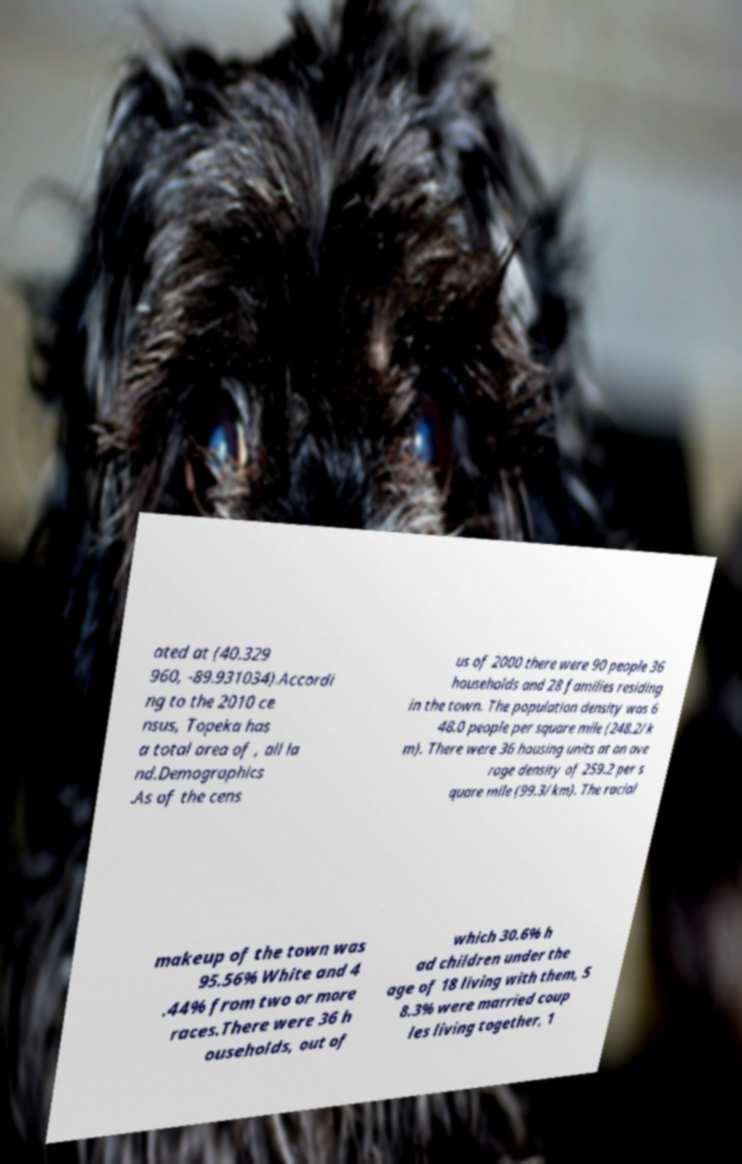Can you read and provide the text displayed in the image?This photo seems to have some interesting text. Can you extract and type it out for me? ated at (40.329 960, -89.931034).Accordi ng to the 2010 ce nsus, Topeka has a total area of , all la nd.Demographics .As of the cens us of 2000 there were 90 people 36 households and 28 families residing in the town. The population density was 6 48.0 people per square mile (248.2/k m). There were 36 housing units at an ave rage density of 259.2 per s quare mile (99.3/km). The racial makeup of the town was 95.56% White and 4 .44% from two or more races.There were 36 h ouseholds, out of which 30.6% h ad children under the age of 18 living with them, 5 8.3% were married coup les living together, 1 